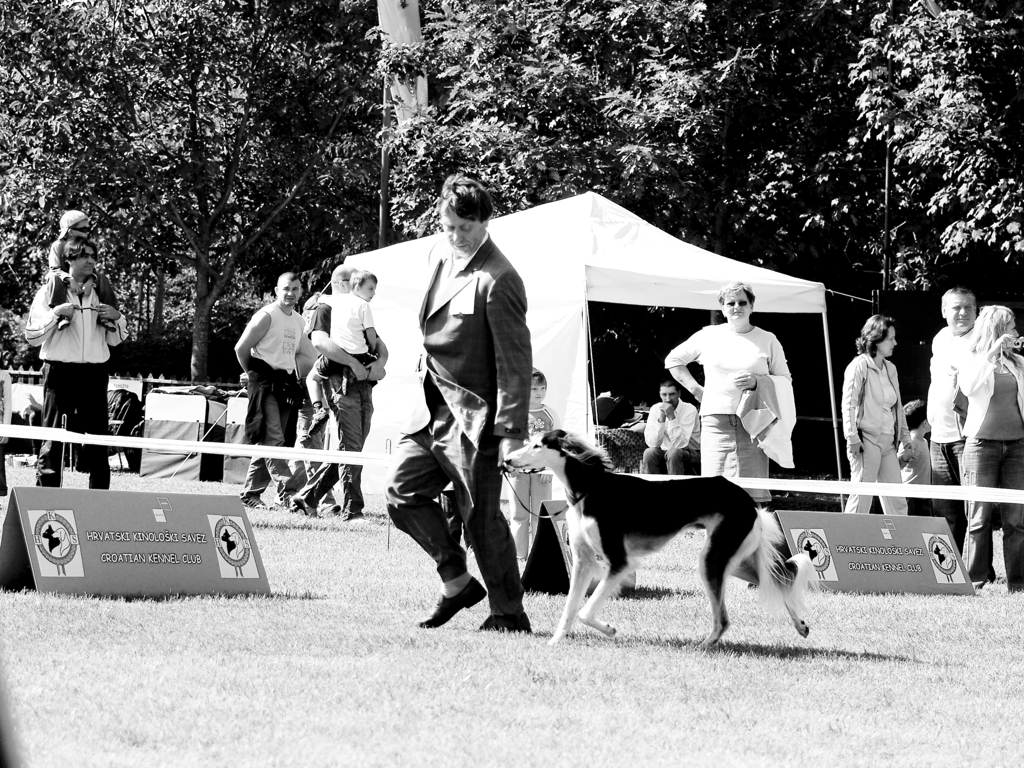What details in the image indicate the type of activity happening? The image shows a person leading a dog across what seems to be a designated show area, with banners that suggest a canine-related event. The presence of an audience watching the event and the official-looking barriers create the impression of a structured activity with spectators, likely a competition or showcase for dogs, such as agility or obedience trials. 